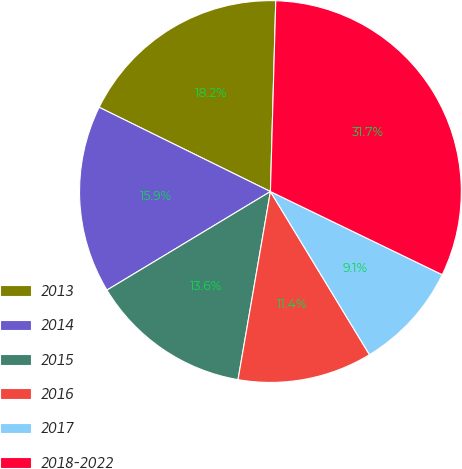Convert chart. <chart><loc_0><loc_0><loc_500><loc_500><pie_chart><fcel>2013<fcel>2014<fcel>2015<fcel>2016<fcel>2017<fcel>2018-2022<nl><fcel>18.17%<fcel>15.91%<fcel>13.65%<fcel>11.4%<fcel>9.14%<fcel>31.73%<nl></chart> 